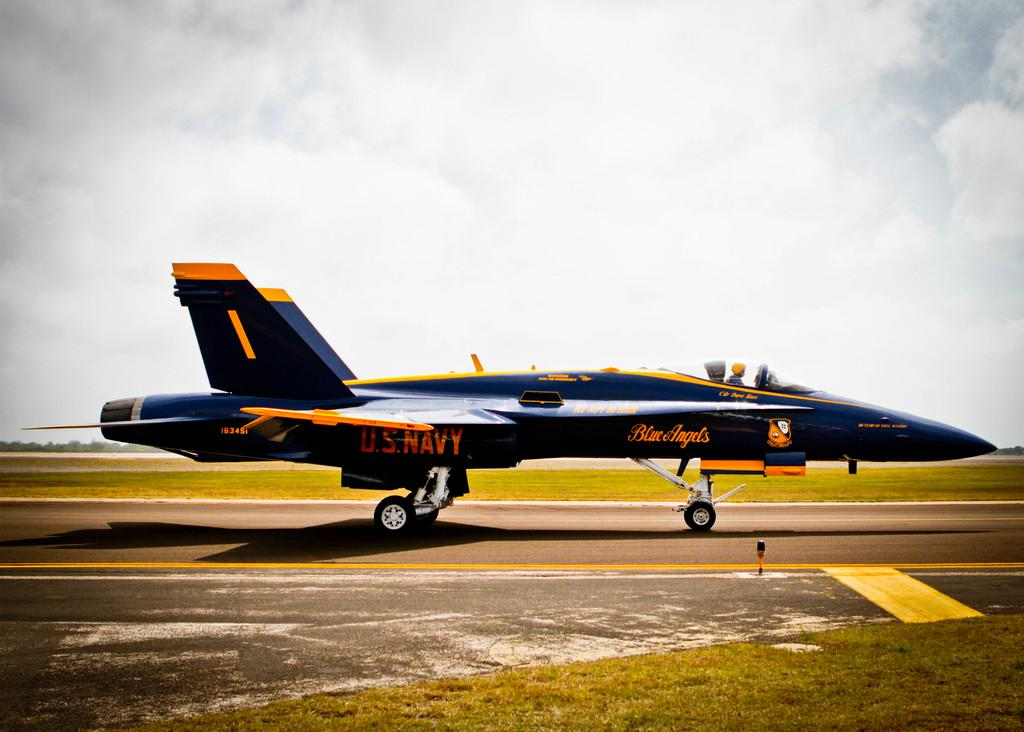What is the main subject of the image? The main subject of the image is a jet plane. Can you describe the position of the jet plane in the image? The jet plane is standing on the ground in the image. What can be seen in the background of the image? There is a cloudy sky in the background of the image. Can you see a jar being kicked in the image? No, there is no jar or any kicking action depicted in the image. 